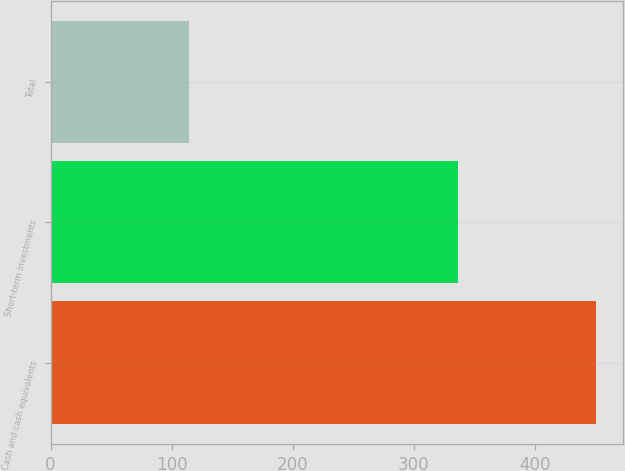<chart> <loc_0><loc_0><loc_500><loc_500><bar_chart><fcel>Cash and cash equivalents<fcel>Short-term investments<fcel>Total<nl><fcel>450<fcel>336<fcel>114<nl></chart> 